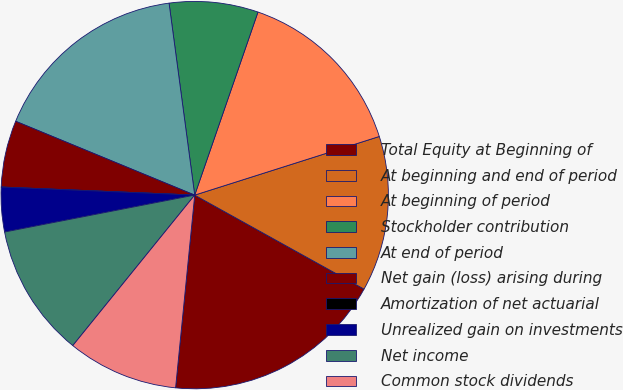Convert chart to OTSL. <chart><loc_0><loc_0><loc_500><loc_500><pie_chart><fcel>Total Equity at Beginning of<fcel>At beginning and end of period<fcel>At beginning of period<fcel>Stockholder contribution<fcel>At end of period<fcel>Net gain (loss) arising during<fcel>Amortization of net actuarial<fcel>Unrealized gain on investments<fcel>Net income<fcel>Common stock dividends<nl><fcel>18.51%<fcel>12.96%<fcel>14.81%<fcel>7.41%<fcel>16.66%<fcel>5.56%<fcel>0.01%<fcel>3.71%<fcel>11.11%<fcel>9.26%<nl></chart> 